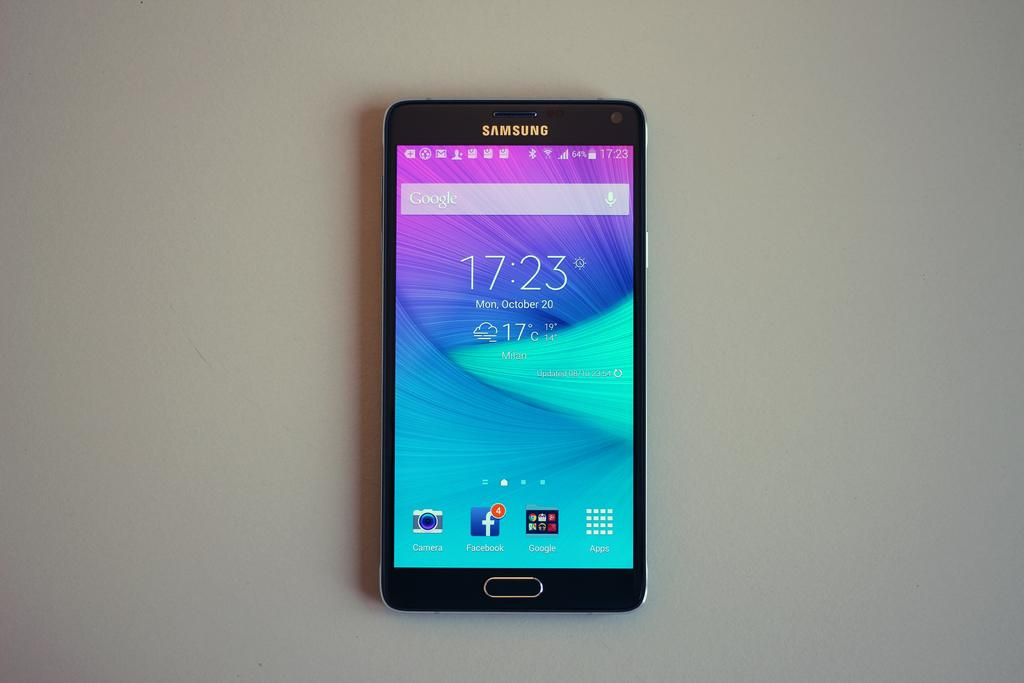<image>
Present a compact description of the photo's key features. samsung android cellphone with google search bar near the top 